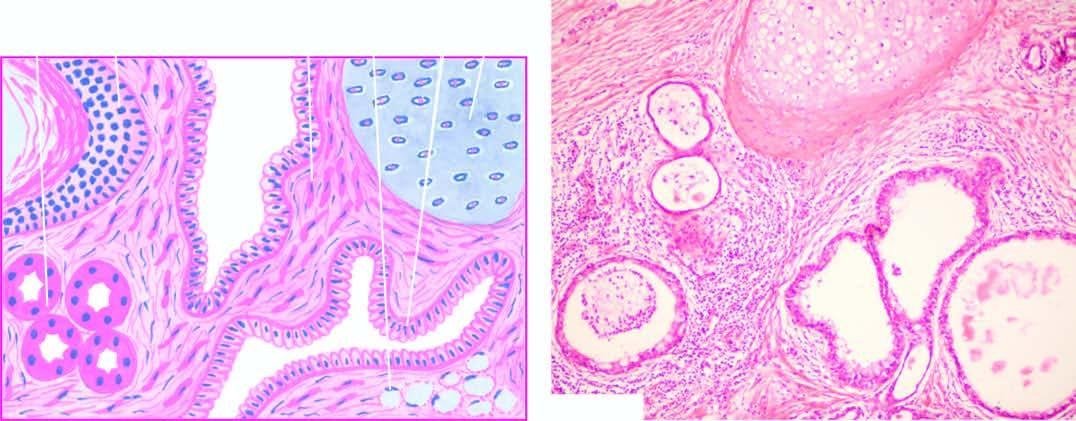re islands of mature cartilage also seen?
Answer the question using a single word or phrase. Yes 